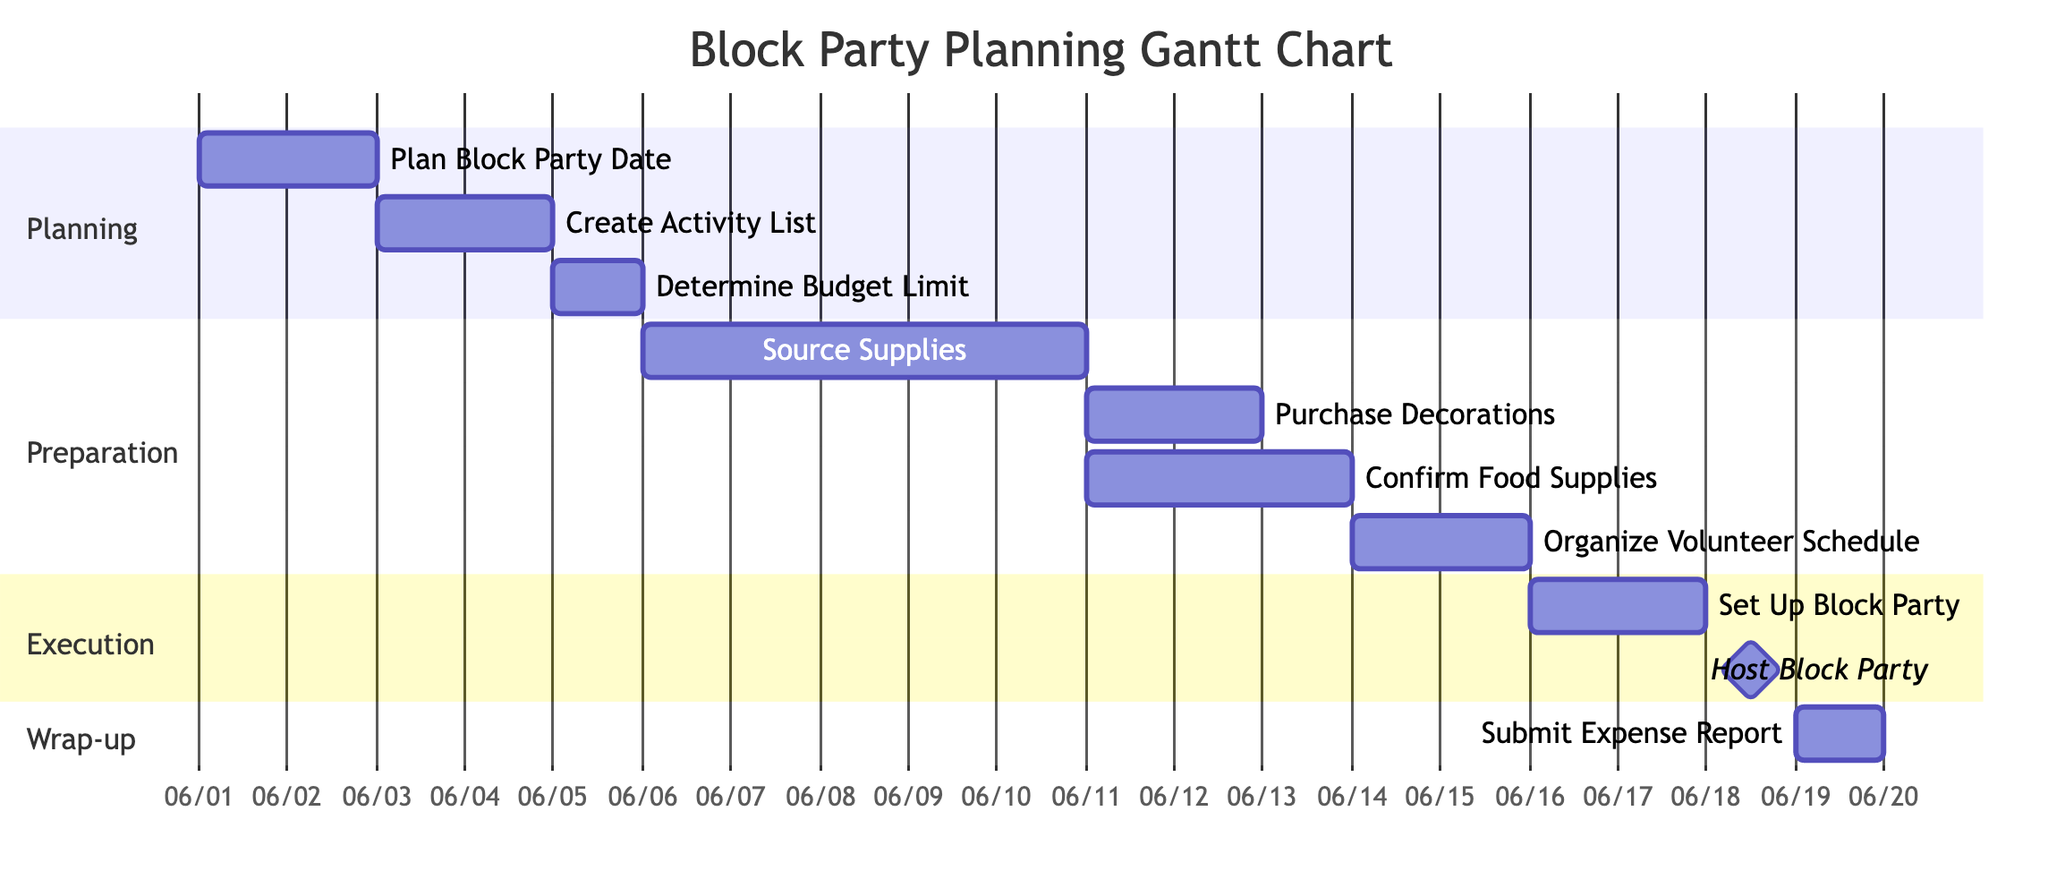What is the start date for the "Host Block Party" activity? According to the diagram, the "Host Block Party" activity starts after the "Set Up Block Party", and the start date of "Set Up Block Party" is June 17, 2024. Therefore, the "Host Block Party" begins on June 19, 2024.
Answer: June 19, 2024 How many days are allocated for "Source Supplies"? The "Source Supplies" activity starts on June 6, 2024, and ends on June 10, 2024. To calculate the duration, you count the total days from start to end, which is 5 days (June 6 to June 10 inclusive).
Answer: 5 days Which activity comes immediately after "Determine Budget Limit"? The "Determine Budget Limit" activity ends on June 5, 2024. The next activity, "Source Supplies", starts immediately after that on June 6, 2024.
Answer: Source Supplies What are the dependencies for "Organize Volunteer Schedule"? The diagram shows that "Organize Volunteer Schedule" has two dependencies: "Confirm Food Supplies" and "Purchase Decorations". Both need to be completed before this activity can start.
Answer: Confirm Food Supplies, Purchase Decorations What is the total number of activities in the Gantt chart? The Gantt chart displays a total of 10 activities, which include all tasks from planning to wrap-up stages.
Answer: 10 activities How long do the wrapping up activities take? The wrapping up activities consist of "Set Up Block Party" (2 days) and "Submit Expense Report" (1 day) that occurs after hosting the block party, making it a total of 3 days.
Answer: 3 days What is the milestone activity in the execution phase? The execution phase has a milestone activity indicating the culmination of the block party event, which is "Host Block Party". This is visually distinguished from the other activities.
Answer: Host Block Party Which activity starts last in the preparation phase? Within the preparation phase, the last activity to start is “Organize Volunteer Schedule.” It begins after "Source Supplies," "Confirm Food Supplies," and "Purchase Decorations" are completed.
Answer: Organize Volunteer Schedule 